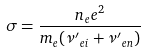<formula> <loc_0><loc_0><loc_500><loc_500>\sigma = \frac { n _ { e } e ^ { 2 } } { m _ { e } ( { \nu ^ { \prime } } _ { e i } + { \nu ^ { \prime } } _ { e n } ) }</formula> 